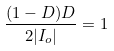Convert formula to latex. <formula><loc_0><loc_0><loc_500><loc_500>\frac { ( 1 - D ) D } { 2 | I _ { o } | } = 1</formula> 